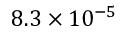Convert formula to latex. <formula><loc_0><loc_0><loc_500><loc_500>8 . 3 \times 1 0 ^ { - 5 }</formula> 